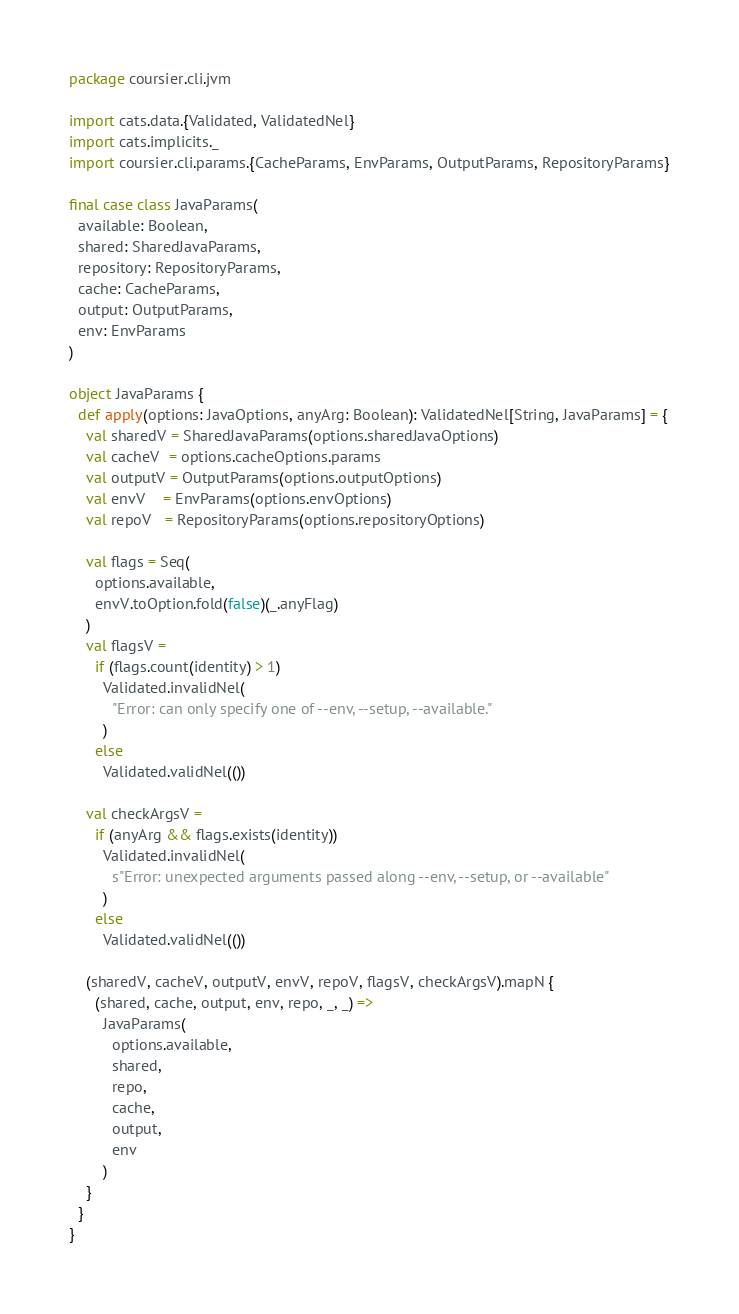Convert code to text. <code><loc_0><loc_0><loc_500><loc_500><_Scala_>package coursier.cli.jvm

import cats.data.{Validated, ValidatedNel}
import cats.implicits._
import coursier.cli.params.{CacheParams, EnvParams, OutputParams, RepositoryParams}

final case class JavaParams(
  available: Boolean,
  shared: SharedJavaParams,
  repository: RepositoryParams,
  cache: CacheParams,
  output: OutputParams,
  env: EnvParams
)

object JavaParams {
  def apply(options: JavaOptions, anyArg: Boolean): ValidatedNel[String, JavaParams] = {
    val sharedV = SharedJavaParams(options.sharedJavaOptions)
    val cacheV  = options.cacheOptions.params
    val outputV = OutputParams(options.outputOptions)
    val envV    = EnvParams(options.envOptions)
    val repoV   = RepositoryParams(options.repositoryOptions)

    val flags = Seq(
      options.available,
      envV.toOption.fold(false)(_.anyFlag)
    )
    val flagsV =
      if (flags.count(identity) > 1)
        Validated.invalidNel(
          "Error: can only specify one of --env, --setup, --available."
        )
      else
        Validated.validNel(())

    val checkArgsV =
      if (anyArg && flags.exists(identity))
        Validated.invalidNel(
          s"Error: unexpected arguments passed along --env, --setup, or --available"
        )
      else
        Validated.validNel(())

    (sharedV, cacheV, outputV, envV, repoV, flagsV, checkArgsV).mapN {
      (shared, cache, output, env, repo, _, _) =>
        JavaParams(
          options.available,
          shared,
          repo,
          cache,
          output,
          env
        )
    }
  }
}
</code> 